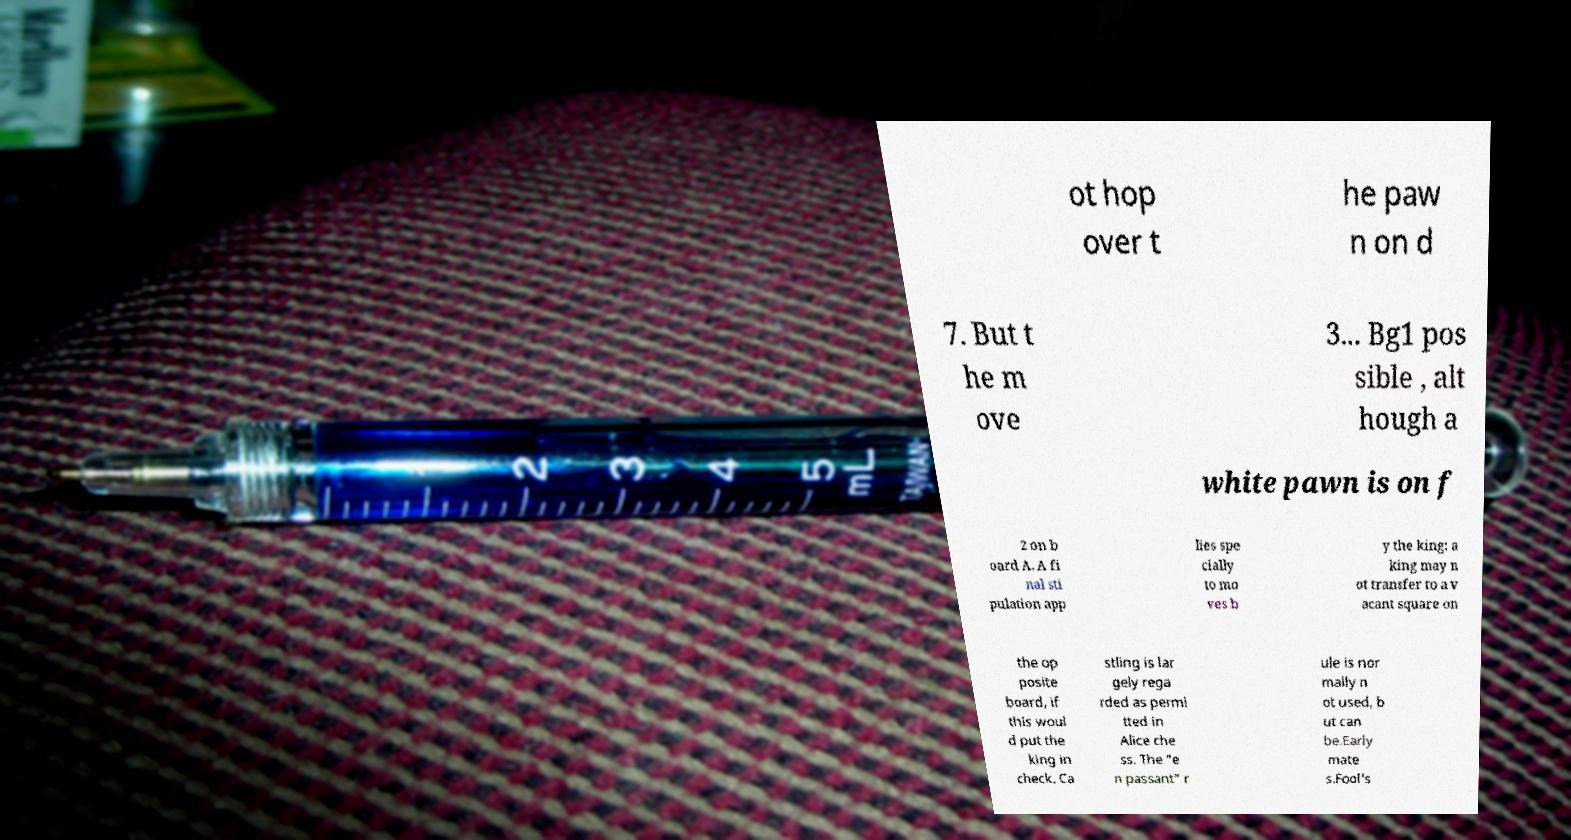Please identify and transcribe the text found in this image. ot hop over t he paw n on d 7. But t he m ove 3... Bg1 pos sible , alt hough a white pawn is on f 2 on b oard A. A fi nal sti pulation app lies spe cially to mo ves b y the king: a king may n ot transfer to a v acant square on the op posite board, if this woul d put the king in check. Ca stling is lar gely rega rded as permi tted in Alice che ss. The "e n passant" r ule is nor mally n ot used, b ut can be.Early mate s.Fool's 